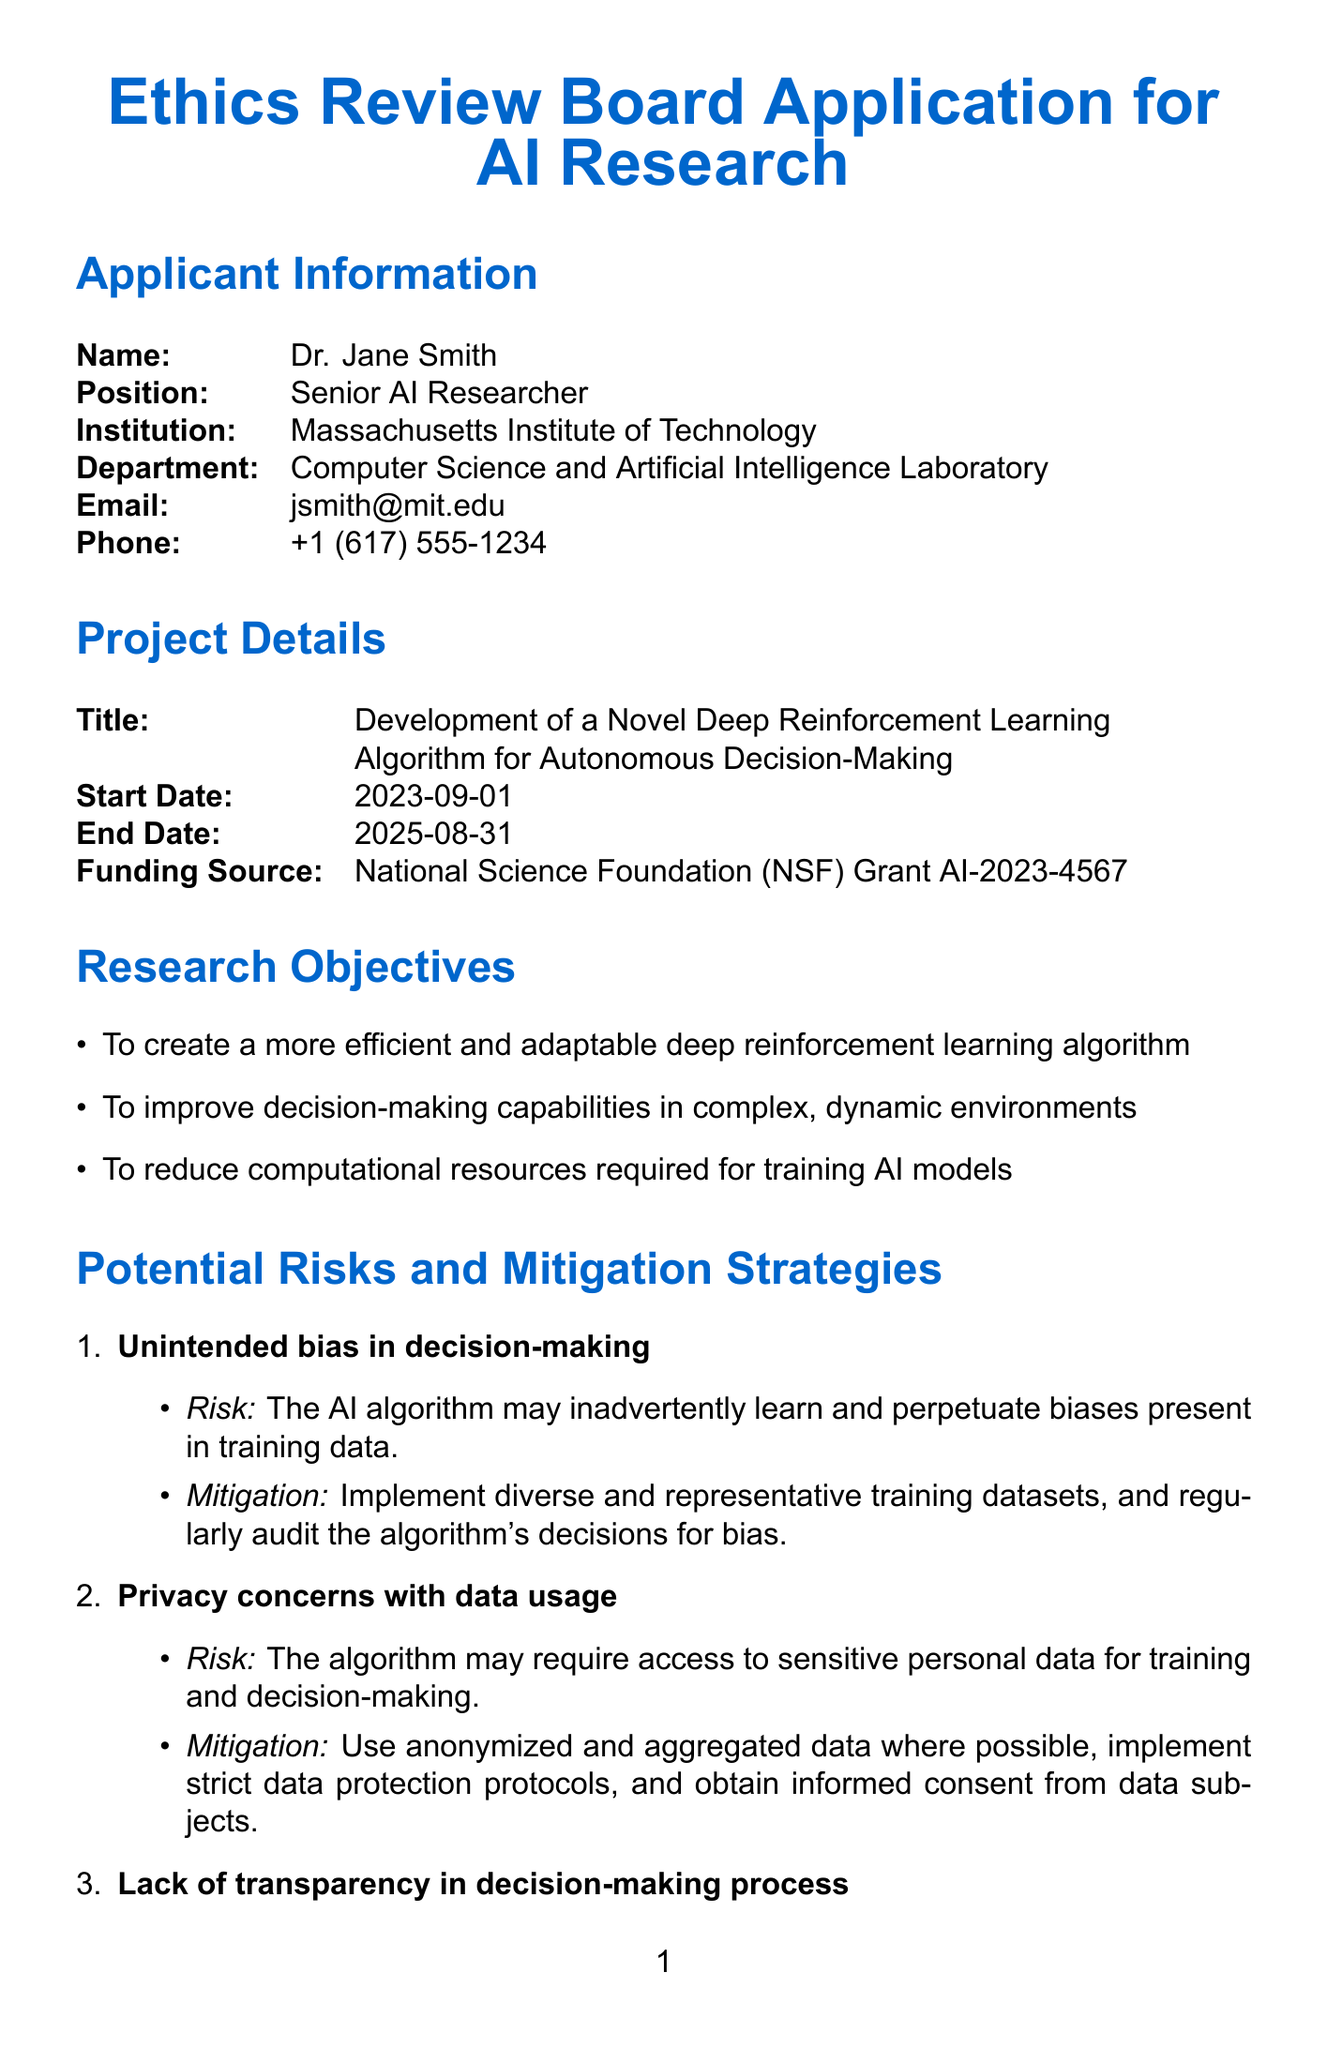What is the title of the project? The title is stated in the project details section, where it mentions "Development of a Novel Deep Reinforcement Learning Algorithm for Autonomous Decision-Making."
Answer: Development of a Novel Deep Reinforcement Learning Algorithm for Autonomous Decision-Making Who is the applicant? The applicant's name is provided in the applicant information section, specifically as "Dr. Jane Smith."
Answer: Dr. Jane Smith What is the duration of the project? The project timeline is detailed in the project details section, with a start date of "2023-09-01" and an end date of "2025-08-31."
Answer: Two years What is the funding source for the project? The funding source is indicated in the project details section as "National Science Foundation (NSF) Grant AI-2023-4567."
Answer: National Science Foundation (NSF) Grant AI-2023-4567 What is one potential risk mentioned in the document? The potential risks are listed in the section dedicated to risks, one example is "Unintended bias in decision-making."
Answer: Unintended bias in decision-making How will privacy concerns be mitigated? The document states specific strategies under the risks section, noting "Use anonymized and aggregated data where possible."
Answer: Use anonymized and aggregated data where possible What is the role of Dr. Michael Chen? The collaborators section specifies Dr. Michael Chen's role, stating he is "Co-investigator, specializing in explainable AI."
Answer: Co-investigator, specializing in explainable AI What is the timeline for the review process? The timeline for the review process is provided in the review process section, stating it takes "4-6 weeks for initial review and feedback."
Answer: 4-6 weeks How long will data be retained after project completion? The data management plan indicates data retention duration as "5 years post-project completion."
Answer: 5 years post-project completion 